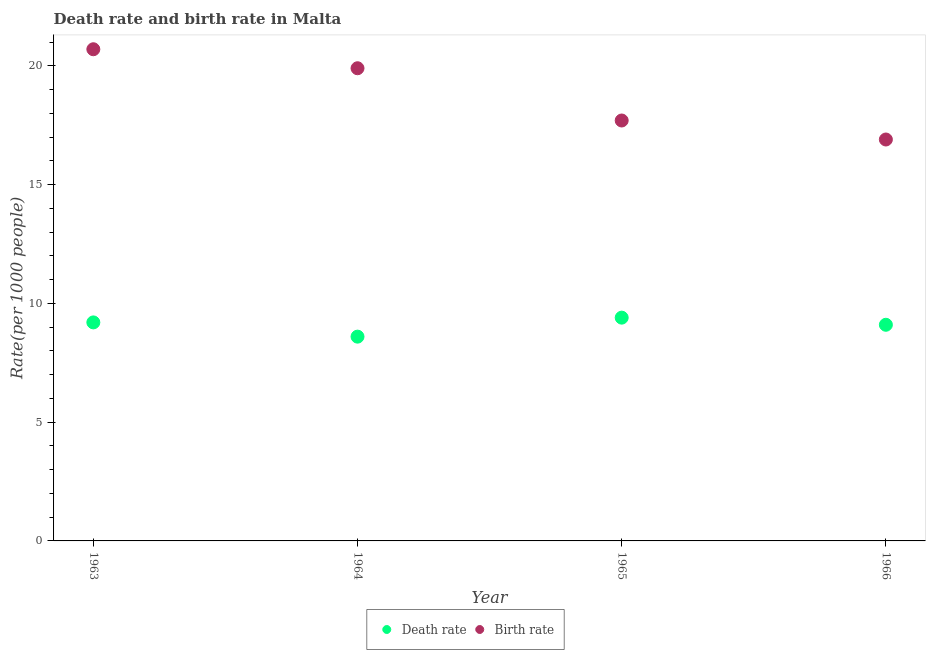How many different coloured dotlines are there?
Provide a short and direct response. 2. Is the number of dotlines equal to the number of legend labels?
Offer a very short reply. Yes. What is the birth rate in 1965?
Your response must be concise. 17.7. Across all years, what is the maximum death rate?
Provide a succinct answer. 9.4. In which year was the birth rate maximum?
Offer a very short reply. 1963. In which year was the death rate minimum?
Your answer should be very brief. 1964. What is the total death rate in the graph?
Your answer should be compact. 36.3. What is the difference between the birth rate in 1964 and that in 1966?
Your response must be concise. 3. What is the difference between the death rate in 1965 and the birth rate in 1964?
Make the answer very short. -10.5. What is the average birth rate per year?
Your answer should be very brief. 18.8. In the year 1964, what is the difference between the birth rate and death rate?
Provide a short and direct response. 11.3. What is the ratio of the death rate in 1963 to that in 1965?
Your answer should be very brief. 0.98. What is the difference between the highest and the second highest birth rate?
Offer a terse response. 0.8. What is the difference between the highest and the lowest birth rate?
Keep it short and to the point. 3.8. In how many years, is the death rate greater than the average death rate taken over all years?
Your response must be concise. 3. Is the sum of the birth rate in 1963 and 1965 greater than the maximum death rate across all years?
Provide a short and direct response. Yes. Does the death rate monotonically increase over the years?
Ensure brevity in your answer.  No. Is the birth rate strictly greater than the death rate over the years?
Provide a succinct answer. Yes. Are the values on the major ticks of Y-axis written in scientific E-notation?
Keep it short and to the point. No. Does the graph contain grids?
Provide a short and direct response. No. How many legend labels are there?
Offer a terse response. 2. How are the legend labels stacked?
Keep it short and to the point. Horizontal. What is the title of the graph?
Your answer should be very brief. Death rate and birth rate in Malta. Does "ODA received" appear as one of the legend labels in the graph?
Offer a very short reply. No. What is the label or title of the X-axis?
Provide a succinct answer. Year. What is the label or title of the Y-axis?
Your answer should be compact. Rate(per 1000 people). What is the Rate(per 1000 people) in Death rate in 1963?
Offer a very short reply. 9.2. What is the Rate(per 1000 people) in Birth rate in 1963?
Make the answer very short. 20.7. What is the Rate(per 1000 people) of Death rate in 1964?
Offer a very short reply. 8.6. What is the Rate(per 1000 people) of Birth rate in 1964?
Provide a short and direct response. 19.9. What is the Rate(per 1000 people) in Death rate in 1965?
Offer a terse response. 9.4. What is the Rate(per 1000 people) of Birth rate in 1966?
Keep it short and to the point. 16.9. Across all years, what is the maximum Rate(per 1000 people) in Birth rate?
Your answer should be very brief. 20.7. What is the total Rate(per 1000 people) in Death rate in the graph?
Ensure brevity in your answer.  36.3. What is the total Rate(per 1000 people) in Birth rate in the graph?
Provide a short and direct response. 75.2. What is the difference between the Rate(per 1000 people) in Birth rate in 1963 and that in 1965?
Your answer should be very brief. 3. What is the difference between the Rate(per 1000 people) of Death rate in 1964 and that in 1965?
Give a very brief answer. -0.8. What is the difference between the Rate(per 1000 people) of Birth rate in 1964 and that in 1965?
Your response must be concise. 2.2. What is the difference between the Rate(per 1000 people) of Birth rate in 1964 and that in 1966?
Ensure brevity in your answer.  3. What is the difference between the Rate(per 1000 people) in Death rate in 1965 and that in 1966?
Make the answer very short. 0.3. What is the difference between the Rate(per 1000 people) in Birth rate in 1965 and that in 1966?
Make the answer very short. 0.8. What is the difference between the Rate(per 1000 people) of Death rate in 1963 and the Rate(per 1000 people) of Birth rate in 1964?
Give a very brief answer. -10.7. What is the difference between the Rate(per 1000 people) in Death rate in 1964 and the Rate(per 1000 people) in Birth rate in 1965?
Offer a very short reply. -9.1. What is the difference between the Rate(per 1000 people) of Death rate in 1964 and the Rate(per 1000 people) of Birth rate in 1966?
Make the answer very short. -8.3. What is the average Rate(per 1000 people) in Death rate per year?
Ensure brevity in your answer.  9.07. What is the average Rate(per 1000 people) in Birth rate per year?
Provide a succinct answer. 18.8. In the year 1965, what is the difference between the Rate(per 1000 people) of Death rate and Rate(per 1000 people) of Birth rate?
Your answer should be compact. -8.3. In the year 1966, what is the difference between the Rate(per 1000 people) of Death rate and Rate(per 1000 people) of Birth rate?
Your answer should be very brief. -7.8. What is the ratio of the Rate(per 1000 people) in Death rate in 1963 to that in 1964?
Provide a succinct answer. 1.07. What is the ratio of the Rate(per 1000 people) of Birth rate in 1963 to that in 1964?
Make the answer very short. 1.04. What is the ratio of the Rate(per 1000 people) in Death rate in 1963 to that in 1965?
Ensure brevity in your answer.  0.98. What is the ratio of the Rate(per 1000 people) of Birth rate in 1963 to that in 1965?
Provide a succinct answer. 1.17. What is the ratio of the Rate(per 1000 people) of Death rate in 1963 to that in 1966?
Your answer should be compact. 1.01. What is the ratio of the Rate(per 1000 people) in Birth rate in 1963 to that in 1966?
Your response must be concise. 1.22. What is the ratio of the Rate(per 1000 people) of Death rate in 1964 to that in 1965?
Offer a terse response. 0.91. What is the ratio of the Rate(per 1000 people) in Birth rate in 1964 to that in 1965?
Your answer should be very brief. 1.12. What is the ratio of the Rate(per 1000 people) in Death rate in 1964 to that in 1966?
Make the answer very short. 0.95. What is the ratio of the Rate(per 1000 people) in Birth rate in 1964 to that in 1966?
Provide a succinct answer. 1.18. What is the ratio of the Rate(per 1000 people) in Death rate in 1965 to that in 1966?
Your answer should be compact. 1.03. What is the ratio of the Rate(per 1000 people) of Birth rate in 1965 to that in 1966?
Ensure brevity in your answer.  1.05. What is the difference between the highest and the lowest Rate(per 1000 people) of Birth rate?
Offer a very short reply. 3.8. 